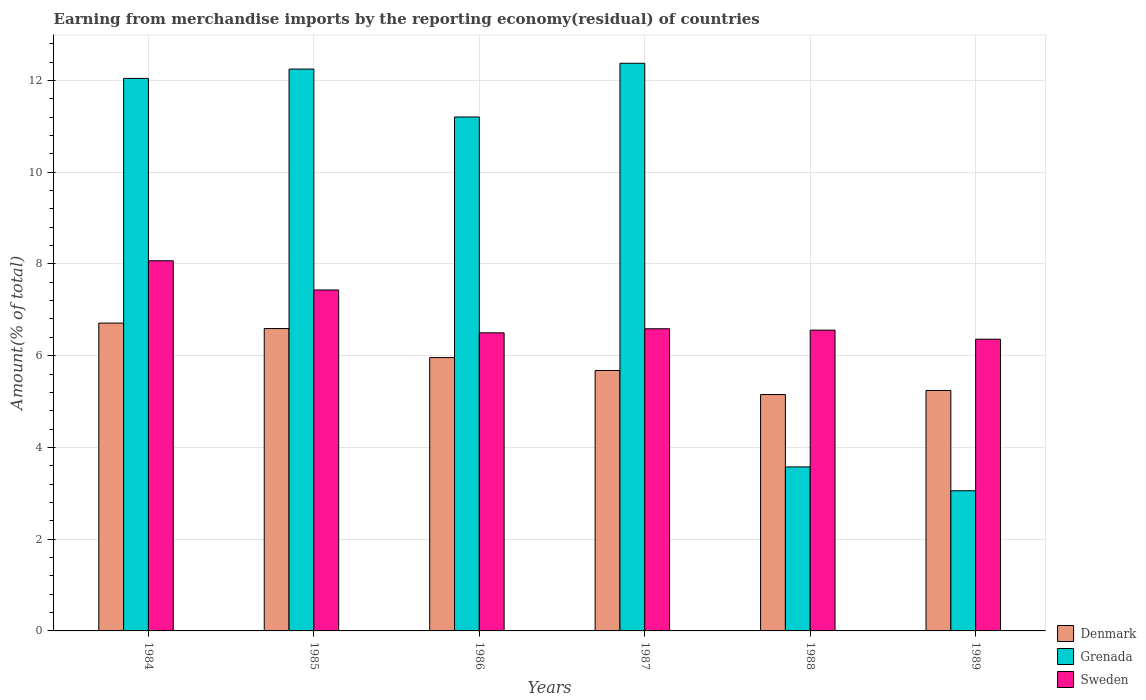How many groups of bars are there?
Make the answer very short. 6. Are the number of bars on each tick of the X-axis equal?
Your response must be concise. Yes. What is the percentage of amount earned from merchandise imports in Denmark in 1985?
Make the answer very short. 6.59. Across all years, what is the maximum percentage of amount earned from merchandise imports in Sweden?
Offer a very short reply. 8.07. Across all years, what is the minimum percentage of amount earned from merchandise imports in Grenada?
Ensure brevity in your answer.  3.06. In which year was the percentage of amount earned from merchandise imports in Sweden maximum?
Your response must be concise. 1984. In which year was the percentage of amount earned from merchandise imports in Denmark minimum?
Keep it short and to the point. 1988. What is the total percentage of amount earned from merchandise imports in Grenada in the graph?
Your answer should be compact. 54.5. What is the difference between the percentage of amount earned from merchandise imports in Denmark in 1986 and that in 1989?
Provide a short and direct response. 0.72. What is the difference between the percentage of amount earned from merchandise imports in Denmark in 1986 and the percentage of amount earned from merchandise imports in Grenada in 1987?
Provide a succinct answer. -6.42. What is the average percentage of amount earned from merchandise imports in Sweden per year?
Give a very brief answer. 6.92. In the year 1988, what is the difference between the percentage of amount earned from merchandise imports in Sweden and percentage of amount earned from merchandise imports in Grenada?
Offer a terse response. 2.98. In how many years, is the percentage of amount earned from merchandise imports in Sweden greater than 10.8 %?
Provide a succinct answer. 0. What is the ratio of the percentage of amount earned from merchandise imports in Grenada in 1984 to that in 1989?
Your response must be concise. 3.94. What is the difference between the highest and the second highest percentage of amount earned from merchandise imports in Denmark?
Provide a short and direct response. 0.12. What is the difference between the highest and the lowest percentage of amount earned from merchandise imports in Sweden?
Give a very brief answer. 1.71. What does the 2nd bar from the left in 1989 represents?
Your answer should be very brief. Grenada. What does the 2nd bar from the right in 1985 represents?
Your answer should be compact. Grenada. How many bars are there?
Offer a terse response. 18. Are the values on the major ticks of Y-axis written in scientific E-notation?
Keep it short and to the point. No. Does the graph contain grids?
Your answer should be very brief. Yes. Where does the legend appear in the graph?
Your answer should be very brief. Bottom right. How many legend labels are there?
Your answer should be very brief. 3. What is the title of the graph?
Keep it short and to the point. Earning from merchandise imports by the reporting economy(residual) of countries. What is the label or title of the X-axis?
Provide a short and direct response. Years. What is the label or title of the Y-axis?
Offer a terse response. Amount(% of total). What is the Amount(% of total) of Denmark in 1984?
Provide a short and direct response. 6.71. What is the Amount(% of total) in Grenada in 1984?
Offer a terse response. 12.04. What is the Amount(% of total) of Sweden in 1984?
Offer a terse response. 8.07. What is the Amount(% of total) of Denmark in 1985?
Provide a short and direct response. 6.59. What is the Amount(% of total) in Grenada in 1985?
Offer a terse response. 12.25. What is the Amount(% of total) of Sweden in 1985?
Your answer should be compact. 7.43. What is the Amount(% of total) of Denmark in 1986?
Provide a succinct answer. 5.96. What is the Amount(% of total) of Grenada in 1986?
Offer a very short reply. 11.2. What is the Amount(% of total) of Sweden in 1986?
Your answer should be very brief. 6.5. What is the Amount(% of total) in Denmark in 1987?
Your response must be concise. 5.68. What is the Amount(% of total) in Grenada in 1987?
Your answer should be very brief. 12.37. What is the Amount(% of total) in Sweden in 1987?
Your response must be concise. 6.59. What is the Amount(% of total) in Denmark in 1988?
Offer a terse response. 5.15. What is the Amount(% of total) of Grenada in 1988?
Provide a short and direct response. 3.58. What is the Amount(% of total) in Sweden in 1988?
Your response must be concise. 6.56. What is the Amount(% of total) of Denmark in 1989?
Make the answer very short. 5.24. What is the Amount(% of total) of Grenada in 1989?
Ensure brevity in your answer.  3.06. What is the Amount(% of total) of Sweden in 1989?
Keep it short and to the point. 6.36. Across all years, what is the maximum Amount(% of total) of Denmark?
Provide a succinct answer. 6.71. Across all years, what is the maximum Amount(% of total) of Grenada?
Your answer should be compact. 12.37. Across all years, what is the maximum Amount(% of total) of Sweden?
Provide a succinct answer. 8.07. Across all years, what is the minimum Amount(% of total) of Denmark?
Provide a short and direct response. 5.15. Across all years, what is the minimum Amount(% of total) of Grenada?
Your answer should be compact. 3.06. Across all years, what is the minimum Amount(% of total) in Sweden?
Your response must be concise. 6.36. What is the total Amount(% of total) in Denmark in the graph?
Offer a terse response. 35.33. What is the total Amount(% of total) in Grenada in the graph?
Give a very brief answer. 54.5. What is the total Amount(% of total) in Sweden in the graph?
Your response must be concise. 41.5. What is the difference between the Amount(% of total) in Denmark in 1984 and that in 1985?
Provide a short and direct response. 0.12. What is the difference between the Amount(% of total) of Grenada in 1984 and that in 1985?
Offer a very short reply. -0.2. What is the difference between the Amount(% of total) in Sweden in 1984 and that in 1985?
Provide a succinct answer. 0.64. What is the difference between the Amount(% of total) in Denmark in 1984 and that in 1986?
Your response must be concise. 0.75. What is the difference between the Amount(% of total) of Grenada in 1984 and that in 1986?
Give a very brief answer. 0.84. What is the difference between the Amount(% of total) of Sweden in 1984 and that in 1986?
Make the answer very short. 1.57. What is the difference between the Amount(% of total) of Denmark in 1984 and that in 1987?
Give a very brief answer. 1.03. What is the difference between the Amount(% of total) of Grenada in 1984 and that in 1987?
Make the answer very short. -0.33. What is the difference between the Amount(% of total) in Sweden in 1984 and that in 1987?
Keep it short and to the point. 1.48. What is the difference between the Amount(% of total) of Denmark in 1984 and that in 1988?
Ensure brevity in your answer.  1.56. What is the difference between the Amount(% of total) in Grenada in 1984 and that in 1988?
Ensure brevity in your answer.  8.47. What is the difference between the Amount(% of total) of Sweden in 1984 and that in 1988?
Your answer should be very brief. 1.51. What is the difference between the Amount(% of total) of Denmark in 1984 and that in 1989?
Provide a succinct answer. 1.47. What is the difference between the Amount(% of total) of Grenada in 1984 and that in 1989?
Your answer should be compact. 8.99. What is the difference between the Amount(% of total) of Sweden in 1984 and that in 1989?
Give a very brief answer. 1.71. What is the difference between the Amount(% of total) of Denmark in 1985 and that in 1986?
Your answer should be very brief. 0.63. What is the difference between the Amount(% of total) of Grenada in 1985 and that in 1986?
Provide a short and direct response. 1.04. What is the difference between the Amount(% of total) in Sweden in 1985 and that in 1986?
Your response must be concise. 0.93. What is the difference between the Amount(% of total) of Denmark in 1985 and that in 1987?
Provide a short and direct response. 0.91. What is the difference between the Amount(% of total) of Grenada in 1985 and that in 1987?
Provide a succinct answer. -0.13. What is the difference between the Amount(% of total) in Sweden in 1985 and that in 1987?
Your answer should be compact. 0.85. What is the difference between the Amount(% of total) in Denmark in 1985 and that in 1988?
Ensure brevity in your answer.  1.44. What is the difference between the Amount(% of total) of Grenada in 1985 and that in 1988?
Keep it short and to the point. 8.67. What is the difference between the Amount(% of total) of Sweden in 1985 and that in 1988?
Your answer should be compact. 0.88. What is the difference between the Amount(% of total) of Denmark in 1985 and that in 1989?
Offer a very short reply. 1.35. What is the difference between the Amount(% of total) of Grenada in 1985 and that in 1989?
Offer a terse response. 9.19. What is the difference between the Amount(% of total) of Sweden in 1985 and that in 1989?
Offer a very short reply. 1.07. What is the difference between the Amount(% of total) of Denmark in 1986 and that in 1987?
Your response must be concise. 0.28. What is the difference between the Amount(% of total) in Grenada in 1986 and that in 1987?
Offer a terse response. -1.17. What is the difference between the Amount(% of total) in Sweden in 1986 and that in 1987?
Make the answer very short. -0.09. What is the difference between the Amount(% of total) in Denmark in 1986 and that in 1988?
Provide a short and direct response. 0.81. What is the difference between the Amount(% of total) in Grenada in 1986 and that in 1988?
Provide a succinct answer. 7.63. What is the difference between the Amount(% of total) in Sweden in 1986 and that in 1988?
Offer a very short reply. -0.06. What is the difference between the Amount(% of total) in Denmark in 1986 and that in 1989?
Your answer should be compact. 0.72. What is the difference between the Amount(% of total) in Grenada in 1986 and that in 1989?
Your answer should be compact. 8.15. What is the difference between the Amount(% of total) in Sweden in 1986 and that in 1989?
Offer a very short reply. 0.14. What is the difference between the Amount(% of total) of Denmark in 1987 and that in 1988?
Offer a terse response. 0.52. What is the difference between the Amount(% of total) in Grenada in 1987 and that in 1988?
Give a very brief answer. 8.8. What is the difference between the Amount(% of total) in Sweden in 1987 and that in 1988?
Make the answer very short. 0.03. What is the difference between the Amount(% of total) of Denmark in 1987 and that in 1989?
Make the answer very short. 0.44. What is the difference between the Amount(% of total) in Grenada in 1987 and that in 1989?
Ensure brevity in your answer.  9.32. What is the difference between the Amount(% of total) of Sweden in 1987 and that in 1989?
Ensure brevity in your answer.  0.23. What is the difference between the Amount(% of total) of Denmark in 1988 and that in 1989?
Your answer should be very brief. -0.09. What is the difference between the Amount(% of total) of Grenada in 1988 and that in 1989?
Your answer should be compact. 0.52. What is the difference between the Amount(% of total) in Sweden in 1988 and that in 1989?
Ensure brevity in your answer.  0.2. What is the difference between the Amount(% of total) of Denmark in 1984 and the Amount(% of total) of Grenada in 1985?
Your answer should be very brief. -5.54. What is the difference between the Amount(% of total) in Denmark in 1984 and the Amount(% of total) in Sweden in 1985?
Provide a short and direct response. -0.72. What is the difference between the Amount(% of total) of Grenada in 1984 and the Amount(% of total) of Sweden in 1985?
Your answer should be very brief. 4.61. What is the difference between the Amount(% of total) in Denmark in 1984 and the Amount(% of total) in Grenada in 1986?
Keep it short and to the point. -4.49. What is the difference between the Amount(% of total) in Denmark in 1984 and the Amount(% of total) in Sweden in 1986?
Ensure brevity in your answer.  0.21. What is the difference between the Amount(% of total) in Grenada in 1984 and the Amount(% of total) in Sweden in 1986?
Your answer should be compact. 5.55. What is the difference between the Amount(% of total) of Denmark in 1984 and the Amount(% of total) of Grenada in 1987?
Keep it short and to the point. -5.66. What is the difference between the Amount(% of total) in Denmark in 1984 and the Amount(% of total) in Sweden in 1987?
Offer a very short reply. 0.12. What is the difference between the Amount(% of total) in Grenada in 1984 and the Amount(% of total) in Sweden in 1987?
Your answer should be compact. 5.46. What is the difference between the Amount(% of total) in Denmark in 1984 and the Amount(% of total) in Grenada in 1988?
Offer a terse response. 3.14. What is the difference between the Amount(% of total) in Denmark in 1984 and the Amount(% of total) in Sweden in 1988?
Make the answer very short. 0.15. What is the difference between the Amount(% of total) of Grenada in 1984 and the Amount(% of total) of Sweden in 1988?
Your response must be concise. 5.49. What is the difference between the Amount(% of total) in Denmark in 1984 and the Amount(% of total) in Grenada in 1989?
Keep it short and to the point. 3.66. What is the difference between the Amount(% of total) in Denmark in 1984 and the Amount(% of total) in Sweden in 1989?
Provide a succinct answer. 0.35. What is the difference between the Amount(% of total) in Grenada in 1984 and the Amount(% of total) in Sweden in 1989?
Provide a short and direct response. 5.69. What is the difference between the Amount(% of total) of Denmark in 1985 and the Amount(% of total) of Grenada in 1986?
Give a very brief answer. -4.61. What is the difference between the Amount(% of total) of Denmark in 1985 and the Amount(% of total) of Sweden in 1986?
Your answer should be very brief. 0.09. What is the difference between the Amount(% of total) of Grenada in 1985 and the Amount(% of total) of Sweden in 1986?
Provide a succinct answer. 5.75. What is the difference between the Amount(% of total) in Denmark in 1985 and the Amount(% of total) in Grenada in 1987?
Provide a short and direct response. -5.78. What is the difference between the Amount(% of total) in Denmark in 1985 and the Amount(% of total) in Sweden in 1987?
Provide a short and direct response. 0. What is the difference between the Amount(% of total) of Grenada in 1985 and the Amount(% of total) of Sweden in 1987?
Offer a very short reply. 5.66. What is the difference between the Amount(% of total) of Denmark in 1985 and the Amount(% of total) of Grenada in 1988?
Provide a succinct answer. 3.02. What is the difference between the Amount(% of total) of Denmark in 1985 and the Amount(% of total) of Sweden in 1988?
Provide a succinct answer. 0.03. What is the difference between the Amount(% of total) of Grenada in 1985 and the Amount(% of total) of Sweden in 1988?
Offer a terse response. 5.69. What is the difference between the Amount(% of total) in Denmark in 1985 and the Amount(% of total) in Grenada in 1989?
Offer a very short reply. 3.54. What is the difference between the Amount(% of total) in Denmark in 1985 and the Amount(% of total) in Sweden in 1989?
Offer a terse response. 0.23. What is the difference between the Amount(% of total) of Grenada in 1985 and the Amount(% of total) of Sweden in 1989?
Give a very brief answer. 5.89. What is the difference between the Amount(% of total) in Denmark in 1986 and the Amount(% of total) in Grenada in 1987?
Give a very brief answer. -6.42. What is the difference between the Amount(% of total) in Denmark in 1986 and the Amount(% of total) in Sweden in 1987?
Keep it short and to the point. -0.63. What is the difference between the Amount(% of total) of Grenada in 1986 and the Amount(% of total) of Sweden in 1987?
Your answer should be very brief. 4.62. What is the difference between the Amount(% of total) of Denmark in 1986 and the Amount(% of total) of Grenada in 1988?
Offer a very short reply. 2.38. What is the difference between the Amount(% of total) in Denmark in 1986 and the Amount(% of total) in Sweden in 1988?
Offer a terse response. -0.6. What is the difference between the Amount(% of total) in Grenada in 1986 and the Amount(% of total) in Sweden in 1988?
Ensure brevity in your answer.  4.65. What is the difference between the Amount(% of total) of Denmark in 1986 and the Amount(% of total) of Grenada in 1989?
Provide a succinct answer. 2.9. What is the difference between the Amount(% of total) in Grenada in 1986 and the Amount(% of total) in Sweden in 1989?
Ensure brevity in your answer.  4.84. What is the difference between the Amount(% of total) of Denmark in 1987 and the Amount(% of total) of Grenada in 1988?
Your response must be concise. 2.1. What is the difference between the Amount(% of total) in Denmark in 1987 and the Amount(% of total) in Sweden in 1988?
Offer a very short reply. -0.88. What is the difference between the Amount(% of total) of Grenada in 1987 and the Amount(% of total) of Sweden in 1988?
Give a very brief answer. 5.82. What is the difference between the Amount(% of total) in Denmark in 1987 and the Amount(% of total) in Grenada in 1989?
Your answer should be very brief. 2.62. What is the difference between the Amount(% of total) of Denmark in 1987 and the Amount(% of total) of Sweden in 1989?
Keep it short and to the point. -0.68. What is the difference between the Amount(% of total) of Grenada in 1987 and the Amount(% of total) of Sweden in 1989?
Make the answer very short. 6.02. What is the difference between the Amount(% of total) of Denmark in 1988 and the Amount(% of total) of Grenada in 1989?
Your answer should be compact. 2.1. What is the difference between the Amount(% of total) in Denmark in 1988 and the Amount(% of total) in Sweden in 1989?
Your response must be concise. -1.21. What is the difference between the Amount(% of total) of Grenada in 1988 and the Amount(% of total) of Sweden in 1989?
Keep it short and to the point. -2.78. What is the average Amount(% of total) in Denmark per year?
Your answer should be very brief. 5.89. What is the average Amount(% of total) of Grenada per year?
Provide a short and direct response. 9.08. What is the average Amount(% of total) in Sweden per year?
Offer a terse response. 6.92. In the year 1984, what is the difference between the Amount(% of total) in Denmark and Amount(% of total) in Grenada?
Make the answer very short. -5.33. In the year 1984, what is the difference between the Amount(% of total) of Denmark and Amount(% of total) of Sweden?
Give a very brief answer. -1.36. In the year 1984, what is the difference between the Amount(% of total) in Grenada and Amount(% of total) in Sweden?
Keep it short and to the point. 3.98. In the year 1985, what is the difference between the Amount(% of total) in Denmark and Amount(% of total) in Grenada?
Your answer should be compact. -5.66. In the year 1985, what is the difference between the Amount(% of total) of Denmark and Amount(% of total) of Sweden?
Your response must be concise. -0.84. In the year 1985, what is the difference between the Amount(% of total) in Grenada and Amount(% of total) in Sweden?
Keep it short and to the point. 4.82. In the year 1986, what is the difference between the Amount(% of total) in Denmark and Amount(% of total) in Grenada?
Keep it short and to the point. -5.24. In the year 1986, what is the difference between the Amount(% of total) in Denmark and Amount(% of total) in Sweden?
Offer a terse response. -0.54. In the year 1986, what is the difference between the Amount(% of total) of Grenada and Amount(% of total) of Sweden?
Offer a very short reply. 4.71. In the year 1987, what is the difference between the Amount(% of total) of Denmark and Amount(% of total) of Grenada?
Make the answer very short. -6.7. In the year 1987, what is the difference between the Amount(% of total) in Denmark and Amount(% of total) in Sweden?
Ensure brevity in your answer.  -0.91. In the year 1987, what is the difference between the Amount(% of total) of Grenada and Amount(% of total) of Sweden?
Make the answer very short. 5.79. In the year 1988, what is the difference between the Amount(% of total) of Denmark and Amount(% of total) of Grenada?
Offer a very short reply. 1.58. In the year 1988, what is the difference between the Amount(% of total) in Denmark and Amount(% of total) in Sweden?
Offer a terse response. -1.4. In the year 1988, what is the difference between the Amount(% of total) in Grenada and Amount(% of total) in Sweden?
Keep it short and to the point. -2.98. In the year 1989, what is the difference between the Amount(% of total) of Denmark and Amount(% of total) of Grenada?
Your answer should be compact. 2.19. In the year 1989, what is the difference between the Amount(% of total) in Denmark and Amount(% of total) in Sweden?
Make the answer very short. -1.12. In the year 1989, what is the difference between the Amount(% of total) in Grenada and Amount(% of total) in Sweden?
Your answer should be very brief. -3.3. What is the ratio of the Amount(% of total) in Denmark in 1984 to that in 1985?
Give a very brief answer. 1.02. What is the ratio of the Amount(% of total) of Grenada in 1984 to that in 1985?
Your answer should be compact. 0.98. What is the ratio of the Amount(% of total) in Sweden in 1984 to that in 1985?
Keep it short and to the point. 1.09. What is the ratio of the Amount(% of total) of Denmark in 1984 to that in 1986?
Your response must be concise. 1.13. What is the ratio of the Amount(% of total) of Grenada in 1984 to that in 1986?
Offer a very short reply. 1.08. What is the ratio of the Amount(% of total) in Sweden in 1984 to that in 1986?
Provide a succinct answer. 1.24. What is the ratio of the Amount(% of total) in Denmark in 1984 to that in 1987?
Offer a terse response. 1.18. What is the ratio of the Amount(% of total) of Grenada in 1984 to that in 1987?
Make the answer very short. 0.97. What is the ratio of the Amount(% of total) of Sweden in 1984 to that in 1987?
Your answer should be compact. 1.23. What is the ratio of the Amount(% of total) of Denmark in 1984 to that in 1988?
Ensure brevity in your answer.  1.3. What is the ratio of the Amount(% of total) in Grenada in 1984 to that in 1988?
Make the answer very short. 3.37. What is the ratio of the Amount(% of total) in Sweden in 1984 to that in 1988?
Offer a very short reply. 1.23. What is the ratio of the Amount(% of total) of Denmark in 1984 to that in 1989?
Offer a terse response. 1.28. What is the ratio of the Amount(% of total) of Grenada in 1984 to that in 1989?
Offer a terse response. 3.94. What is the ratio of the Amount(% of total) of Sweden in 1984 to that in 1989?
Your answer should be compact. 1.27. What is the ratio of the Amount(% of total) of Denmark in 1985 to that in 1986?
Your answer should be very brief. 1.11. What is the ratio of the Amount(% of total) in Grenada in 1985 to that in 1986?
Make the answer very short. 1.09. What is the ratio of the Amount(% of total) in Sweden in 1985 to that in 1986?
Make the answer very short. 1.14. What is the ratio of the Amount(% of total) in Denmark in 1985 to that in 1987?
Provide a short and direct response. 1.16. What is the ratio of the Amount(% of total) of Sweden in 1985 to that in 1987?
Offer a terse response. 1.13. What is the ratio of the Amount(% of total) of Denmark in 1985 to that in 1988?
Provide a succinct answer. 1.28. What is the ratio of the Amount(% of total) in Grenada in 1985 to that in 1988?
Your answer should be compact. 3.43. What is the ratio of the Amount(% of total) in Sweden in 1985 to that in 1988?
Ensure brevity in your answer.  1.13. What is the ratio of the Amount(% of total) in Denmark in 1985 to that in 1989?
Offer a very short reply. 1.26. What is the ratio of the Amount(% of total) of Grenada in 1985 to that in 1989?
Make the answer very short. 4.01. What is the ratio of the Amount(% of total) in Sweden in 1985 to that in 1989?
Ensure brevity in your answer.  1.17. What is the ratio of the Amount(% of total) of Denmark in 1986 to that in 1987?
Keep it short and to the point. 1.05. What is the ratio of the Amount(% of total) in Grenada in 1986 to that in 1987?
Offer a terse response. 0.91. What is the ratio of the Amount(% of total) of Sweden in 1986 to that in 1987?
Offer a terse response. 0.99. What is the ratio of the Amount(% of total) in Denmark in 1986 to that in 1988?
Provide a succinct answer. 1.16. What is the ratio of the Amount(% of total) of Grenada in 1986 to that in 1988?
Your response must be concise. 3.13. What is the ratio of the Amount(% of total) in Sweden in 1986 to that in 1988?
Offer a very short reply. 0.99. What is the ratio of the Amount(% of total) of Denmark in 1986 to that in 1989?
Give a very brief answer. 1.14. What is the ratio of the Amount(% of total) in Grenada in 1986 to that in 1989?
Your response must be concise. 3.67. What is the ratio of the Amount(% of total) of Sweden in 1986 to that in 1989?
Offer a terse response. 1.02. What is the ratio of the Amount(% of total) of Denmark in 1987 to that in 1988?
Provide a short and direct response. 1.1. What is the ratio of the Amount(% of total) in Grenada in 1987 to that in 1988?
Provide a succinct answer. 3.46. What is the ratio of the Amount(% of total) in Sweden in 1987 to that in 1988?
Give a very brief answer. 1. What is the ratio of the Amount(% of total) of Denmark in 1987 to that in 1989?
Provide a short and direct response. 1.08. What is the ratio of the Amount(% of total) in Grenada in 1987 to that in 1989?
Keep it short and to the point. 4.05. What is the ratio of the Amount(% of total) of Sweden in 1987 to that in 1989?
Your answer should be very brief. 1.04. What is the ratio of the Amount(% of total) in Denmark in 1988 to that in 1989?
Your answer should be very brief. 0.98. What is the ratio of the Amount(% of total) of Grenada in 1988 to that in 1989?
Your response must be concise. 1.17. What is the ratio of the Amount(% of total) in Sweden in 1988 to that in 1989?
Your response must be concise. 1.03. What is the difference between the highest and the second highest Amount(% of total) in Denmark?
Make the answer very short. 0.12. What is the difference between the highest and the second highest Amount(% of total) of Grenada?
Make the answer very short. 0.13. What is the difference between the highest and the second highest Amount(% of total) of Sweden?
Ensure brevity in your answer.  0.64. What is the difference between the highest and the lowest Amount(% of total) of Denmark?
Give a very brief answer. 1.56. What is the difference between the highest and the lowest Amount(% of total) in Grenada?
Your answer should be compact. 9.32. What is the difference between the highest and the lowest Amount(% of total) of Sweden?
Provide a succinct answer. 1.71. 